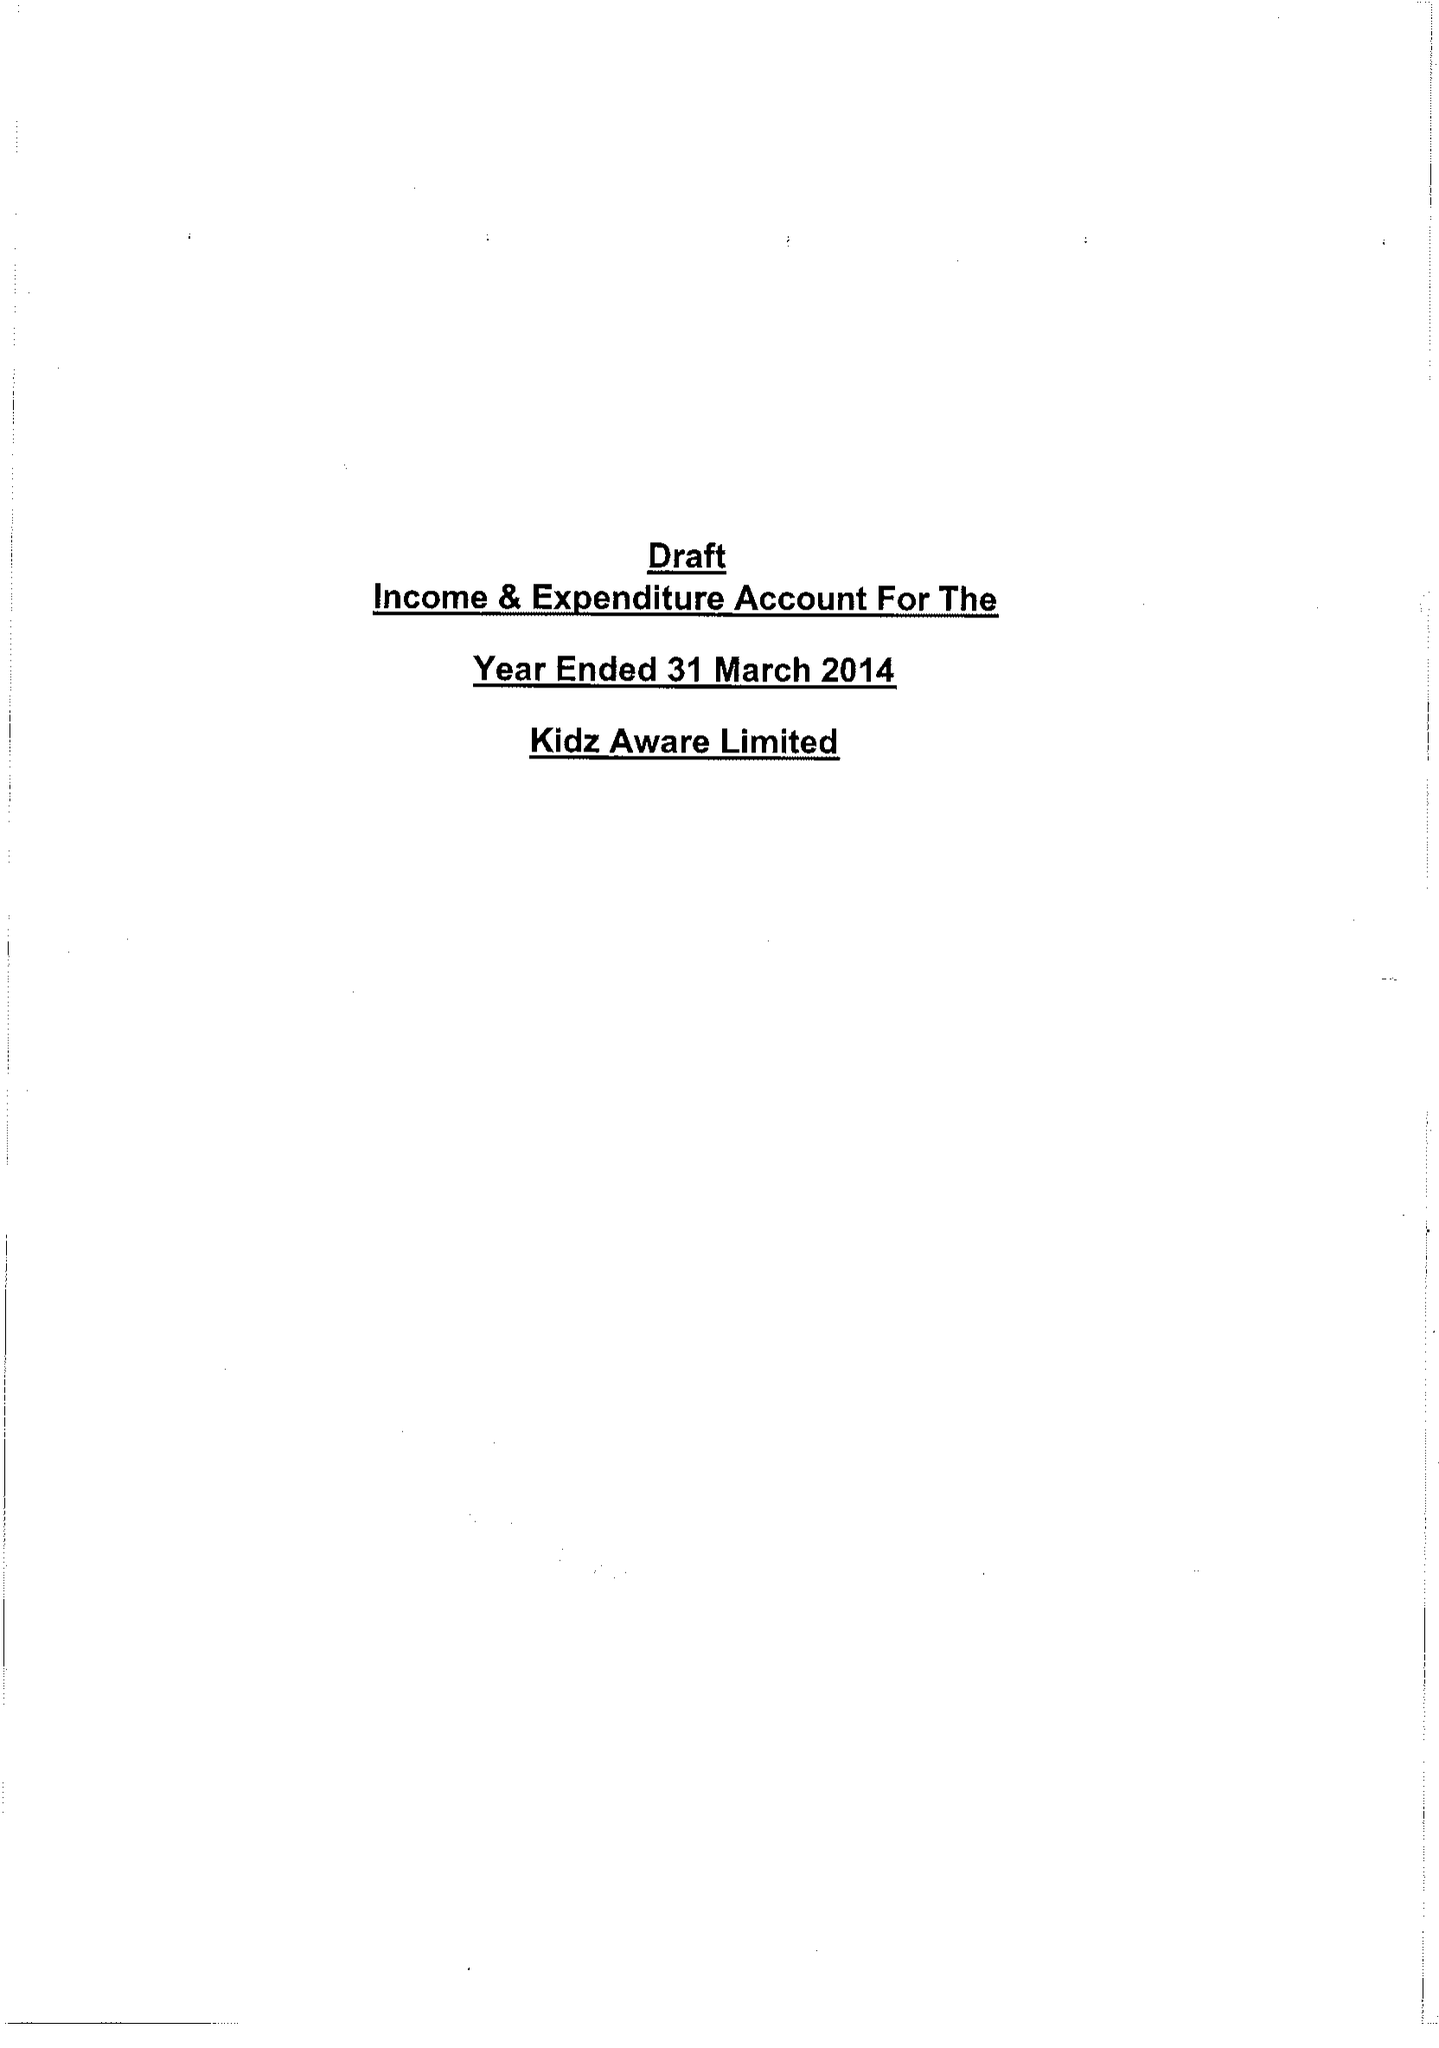What is the value for the address__street_line?
Answer the question using a single word or phrase. DENBY DALE ROAD 